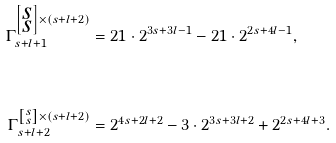Convert formula to latex. <formula><loc_0><loc_0><loc_500><loc_500>\Gamma _ { s + l + 1 } ^ { \left [ \substack { s \\ s } \right ] \times ( s + l + 2 ) } & = 2 1 \cdot 2 ^ { 3 s + 3 l - 1 } - 2 1 \cdot 2 ^ { 2 s + 4 l - 1 } , \\ & \\ \Gamma _ { s + l + 2 } ^ { \left [ \substack { s \\ s } \right ] \times ( s + l + 2 ) } & = 2 ^ { 4 s + 2 l + 2 } - 3 \cdot 2 ^ { 3 s + 3 l + 2 } + 2 ^ { 2 s + 4 l + 3 } . \\ &</formula> 